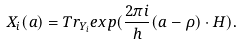Convert formula to latex. <formula><loc_0><loc_0><loc_500><loc_500>X _ { i } ( a ) = T r _ { Y _ { i } } e x p ( \frac { 2 \pi i } h ( a - \rho ) \cdot H ) .</formula> 